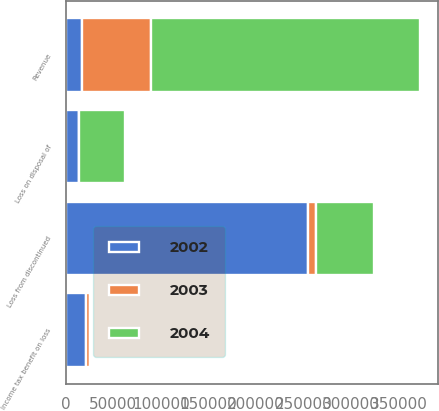Convert chart. <chart><loc_0><loc_0><loc_500><loc_500><stacked_bar_chart><ecel><fcel>Revenue<fcel>Loss from discontinued<fcel>Income tax benefit on loss<fcel>Loss on disposal of<nl><fcel>2003<fcel>71993<fcel>8345<fcel>4101<fcel>625<nl><fcel>2004<fcel>283124<fcel>60475<fcel>1587<fcel>48458<nl><fcel>2002<fcel>17200.5<fcel>255119<fcel>20797<fcel>13510<nl></chart> 